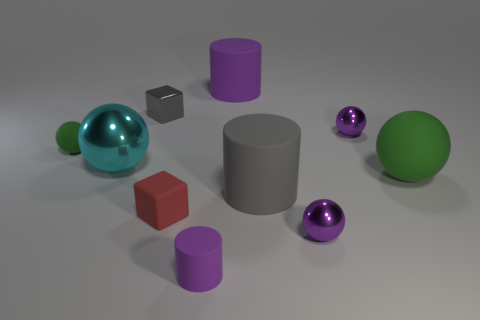There is a tiny object in front of the sphere in front of the big gray object; what color is it?
Your answer should be very brief. Purple. What number of big objects are both left of the gray cylinder and in front of the large purple thing?
Your answer should be very brief. 1. Is the number of large purple matte objects greater than the number of large cylinders?
Provide a short and direct response. No. What is the material of the big cyan ball?
Your answer should be very brief. Metal. There is a green sphere left of the tiny purple rubber thing; what number of large gray matte objects are behind it?
Provide a succinct answer. 0. Do the large rubber ball and the small matte object behind the large gray thing have the same color?
Provide a succinct answer. Yes. What color is the shiny cube that is the same size as the red object?
Offer a very short reply. Gray. Are there any big green things that have the same shape as the cyan thing?
Offer a terse response. Yes. Are there fewer small purple balls than big purple rubber objects?
Ensure brevity in your answer.  No. There is a small rubber object behind the cyan ball; what color is it?
Provide a short and direct response. Green. 